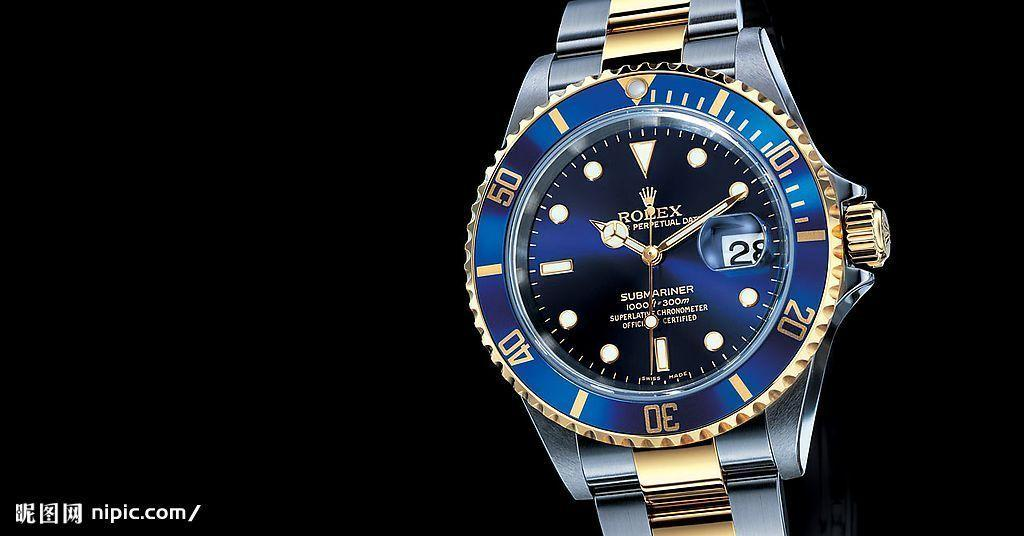<image>
Create a compact narrative representing the image presented. Rolex officially certified Submariner gold men's watch with blue metallic face, wind function on side. 